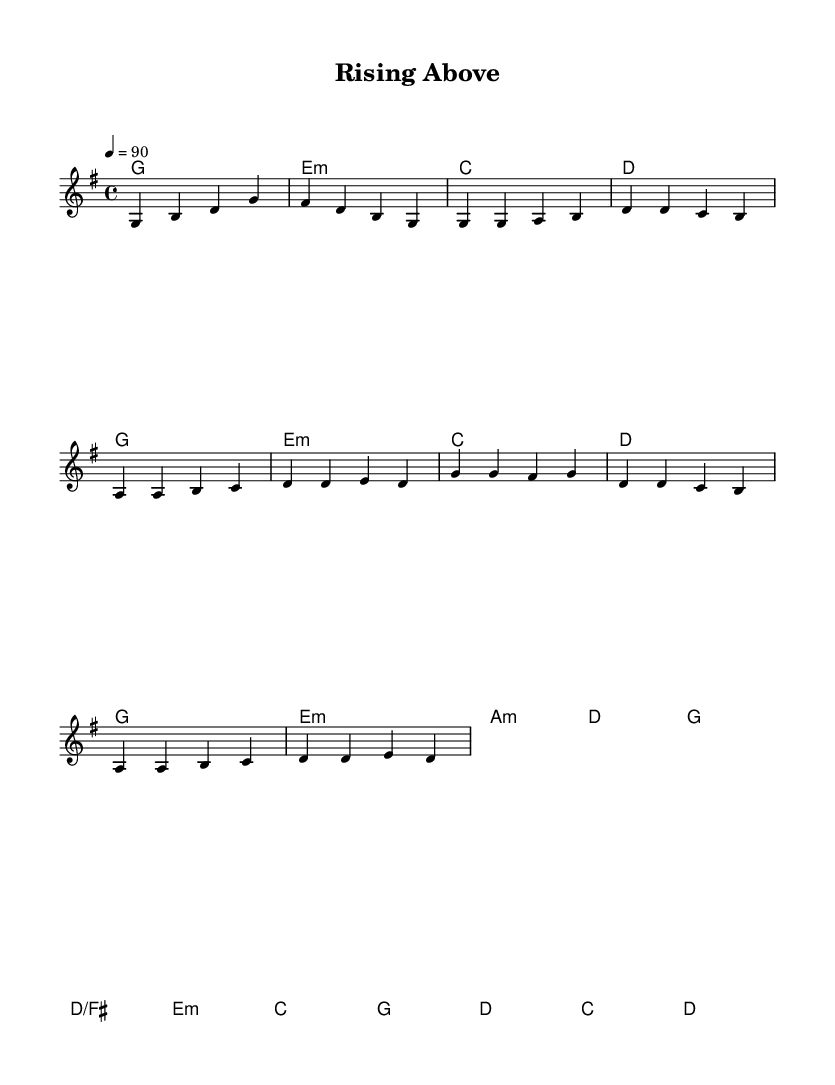What is the key signature of this music? The key signature is G major, which has one sharp (F#).
Answer: G major What time signature is used in the piece? The time signature shown in the sheet music indicates a 4/4 meter, which means there are four beats in each measure and the quarter note gets one beat.
Answer: 4/4 What is the tempo marking for this piece? The tempo marking is quarter note equals 90, indicating that the piece should be played at a speed of 90 beats per minute.
Answer: 90 How many measures are in the verse? The verse consists of 7 measures as indicated by the measures in the melody section that correspond to the lyrics provided.
Answer: 7 What are the first three chords in the piece? The first three chords in the score are G major, E minor, and C major as outlined in the harmonies section of the sheet music.
Answer: G, E minor, C In which phrase does the chorus begin? The chorus starts after the verse, specifically indicated after the lyrical lines associated with the melody where it transitions to a higher melody line.
Answer: After verse 